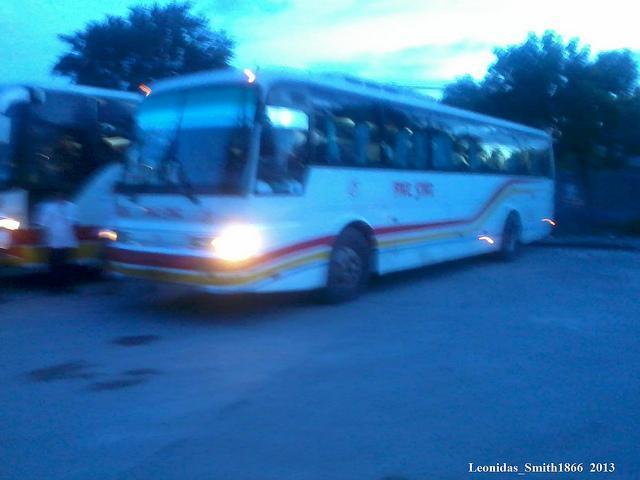How many buses are there?
Give a very brief answer. 2. How many buses are in the picture?
Give a very brief answer. 2. How many books on the hand are there?
Give a very brief answer. 0. 